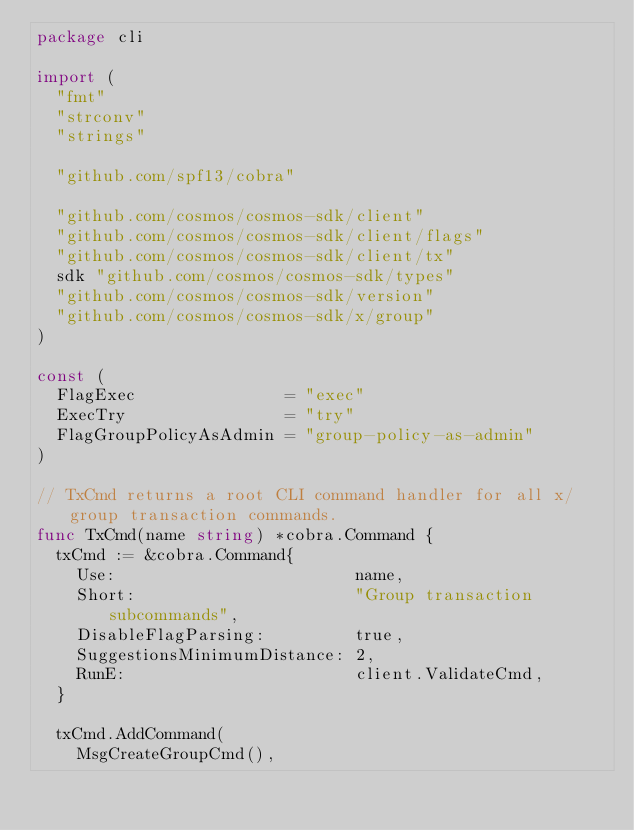Convert code to text. <code><loc_0><loc_0><loc_500><loc_500><_Go_>package cli

import (
	"fmt"
	"strconv"
	"strings"

	"github.com/spf13/cobra"

	"github.com/cosmos/cosmos-sdk/client"
	"github.com/cosmos/cosmos-sdk/client/flags"
	"github.com/cosmos/cosmos-sdk/client/tx"
	sdk "github.com/cosmos/cosmos-sdk/types"
	"github.com/cosmos/cosmos-sdk/version"
	"github.com/cosmos/cosmos-sdk/x/group"
)

const (
	FlagExec               = "exec"
	ExecTry                = "try"
	FlagGroupPolicyAsAdmin = "group-policy-as-admin"
)

// TxCmd returns a root CLI command handler for all x/group transaction commands.
func TxCmd(name string) *cobra.Command {
	txCmd := &cobra.Command{
		Use:                        name,
		Short:                      "Group transaction subcommands",
		DisableFlagParsing:         true,
		SuggestionsMinimumDistance: 2,
		RunE:                       client.ValidateCmd,
	}

	txCmd.AddCommand(
		MsgCreateGroupCmd(),</code> 